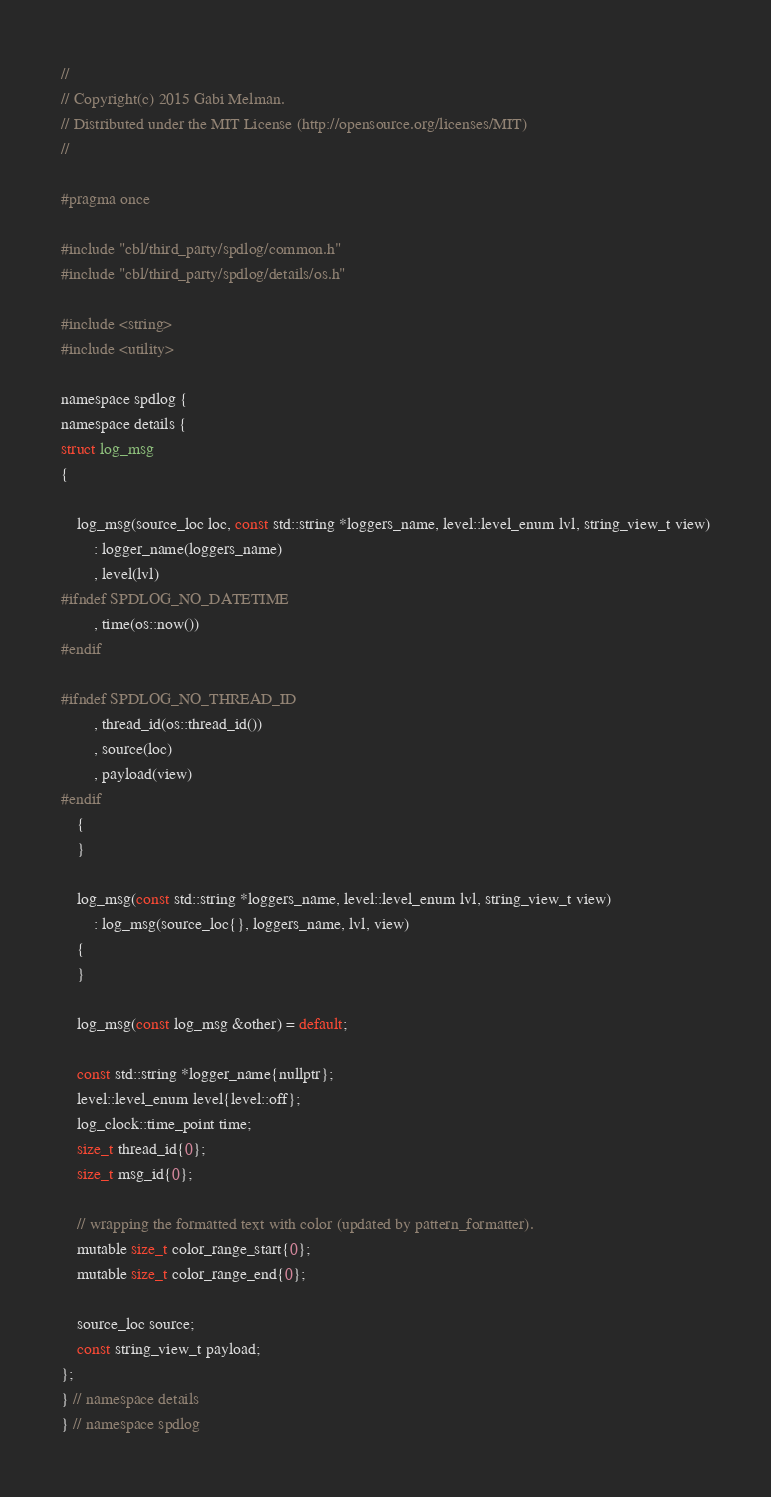Convert code to text. <code><loc_0><loc_0><loc_500><loc_500><_C_>//
// Copyright(c) 2015 Gabi Melman.
// Distributed under the MIT License (http://opensource.org/licenses/MIT)
//

#pragma once

#include "cbl/third_party/spdlog/common.h"
#include "cbl/third_party/spdlog/details/os.h"

#include <string>
#include <utility>

namespace spdlog {
namespace details {
struct log_msg
{

    log_msg(source_loc loc, const std::string *loggers_name, level::level_enum lvl, string_view_t view)
        : logger_name(loggers_name)
        , level(lvl)
#ifndef SPDLOG_NO_DATETIME
        , time(os::now())
#endif

#ifndef SPDLOG_NO_THREAD_ID
        , thread_id(os::thread_id())
        , source(loc)
        , payload(view)
#endif
    {
    }

    log_msg(const std::string *loggers_name, level::level_enum lvl, string_view_t view)
        : log_msg(source_loc{}, loggers_name, lvl, view)
    {
    }

    log_msg(const log_msg &other) = default;

    const std::string *logger_name{nullptr};
    level::level_enum level{level::off};
    log_clock::time_point time;
    size_t thread_id{0};
    size_t msg_id{0};

    // wrapping the formatted text with color (updated by pattern_formatter).
    mutable size_t color_range_start{0};
    mutable size_t color_range_end{0};

    source_loc source;
    const string_view_t payload;
};
} // namespace details
} // namespace spdlog
</code> 